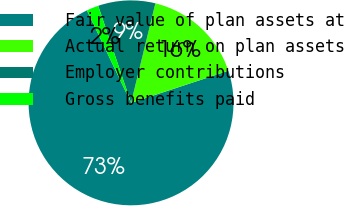<chart> <loc_0><loc_0><loc_500><loc_500><pie_chart><fcel>Fair value of plan assets at<fcel>Actual return on plan assets<fcel>Employer contributions<fcel>Gross benefits paid<nl><fcel>72.97%<fcel>16.12%<fcel>9.01%<fcel>1.9%<nl></chart> 